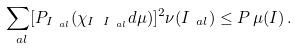<formula> <loc_0><loc_0><loc_500><loc_500>\sum _ { \ a l } [ P _ { I _ { \ a l } } ( \chi _ { I \ I _ { \ a l } } d \mu ) ] ^ { 2 } \nu ( I _ { \ a l } ) \leq P \, \mu ( I ) \, .</formula> 